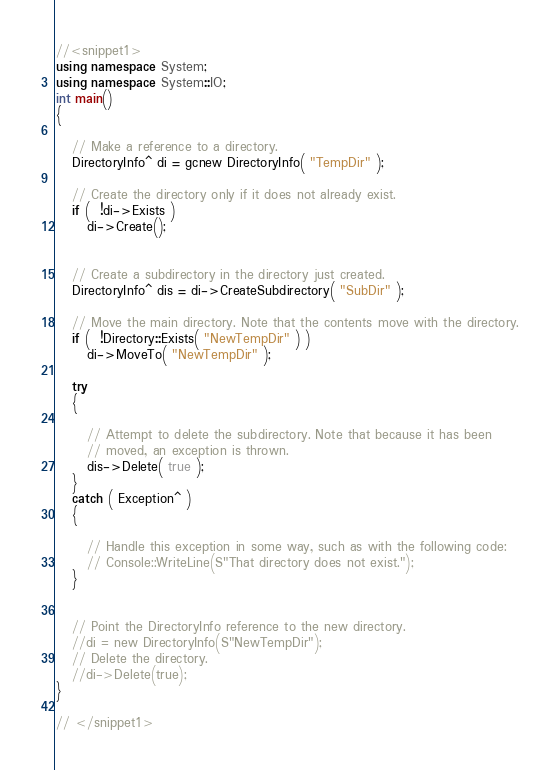Convert code to text. <code><loc_0><loc_0><loc_500><loc_500><_C++_>
//<snippet1>
using namespace System;
using namespace System::IO;
int main()
{
   
   // Make a reference to a directory.
   DirectoryInfo^ di = gcnew DirectoryInfo( "TempDir" );
   
   // Create the directory only if it does not already exist.
   if (  !di->Exists )
      di->Create();

   
   // Create a subdirectory in the directory just created.
   DirectoryInfo^ dis = di->CreateSubdirectory( "SubDir" );
   
   // Move the main directory. Note that the contents move with the directory.
   if (  !Directory::Exists( "NewTempDir" ) )
      di->MoveTo( "NewTempDir" );

   try
   {
      
      // Attempt to delete the subdirectory. Note that because it has been
      // moved, an exception is thrown.
      dis->Delete( true );
   }
   catch ( Exception^ ) 
   {
      
      // Handle this exception in some way, such as with the following code:
      // Console::WriteLine(S"That directory does not exist.");
   }

   
   // Point the DirectoryInfo reference to the new directory.
   //di = new DirectoryInfo(S"NewTempDir");
   // Delete the directory.
   //di->Delete(true);
}

// </snippet1>
</code> 